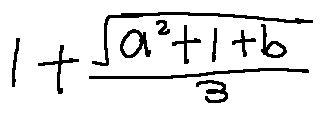<formula> <loc_0><loc_0><loc_500><loc_500>1 + \frac { \sqrt { a ^ { 2 } + 1 + b } } { 3 }</formula> 